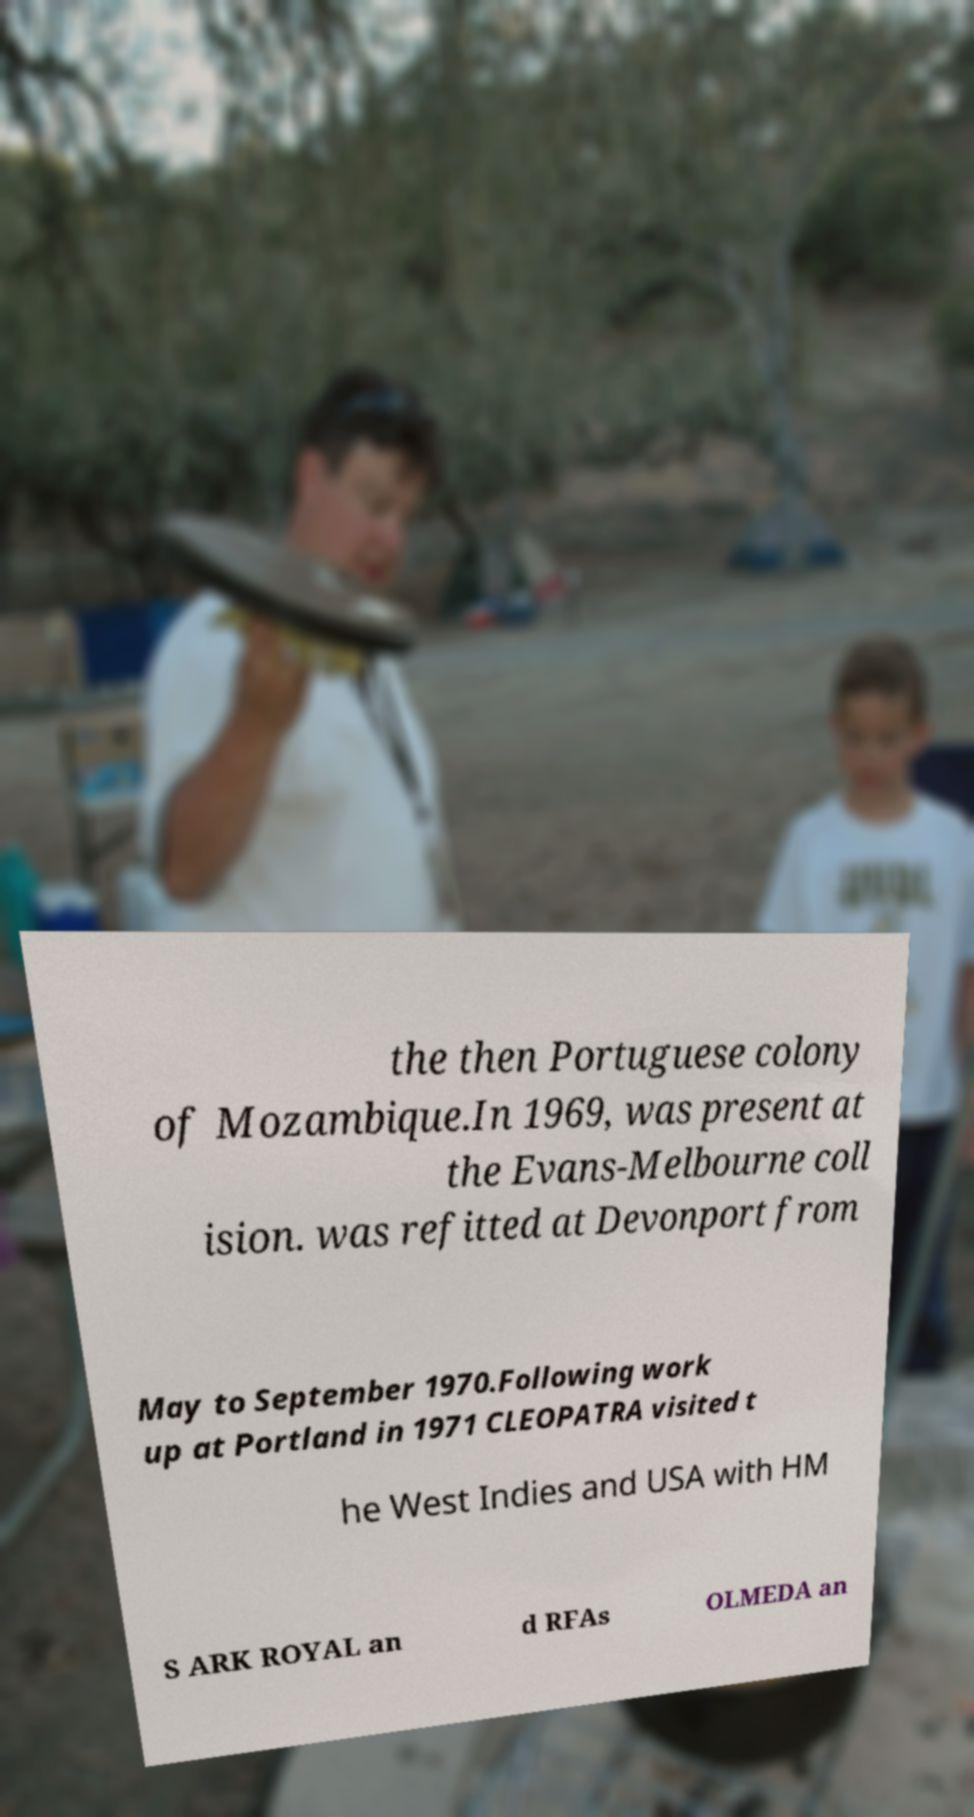Could you assist in decoding the text presented in this image and type it out clearly? the then Portuguese colony of Mozambique.In 1969, was present at the Evans-Melbourne coll ision. was refitted at Devonport from May to September 1970.Following work up at Portland in 1971 CLEOPATRA visited t he West Indies and USA with HM S ARK ROYAL an d RFAs OLMEDA an 